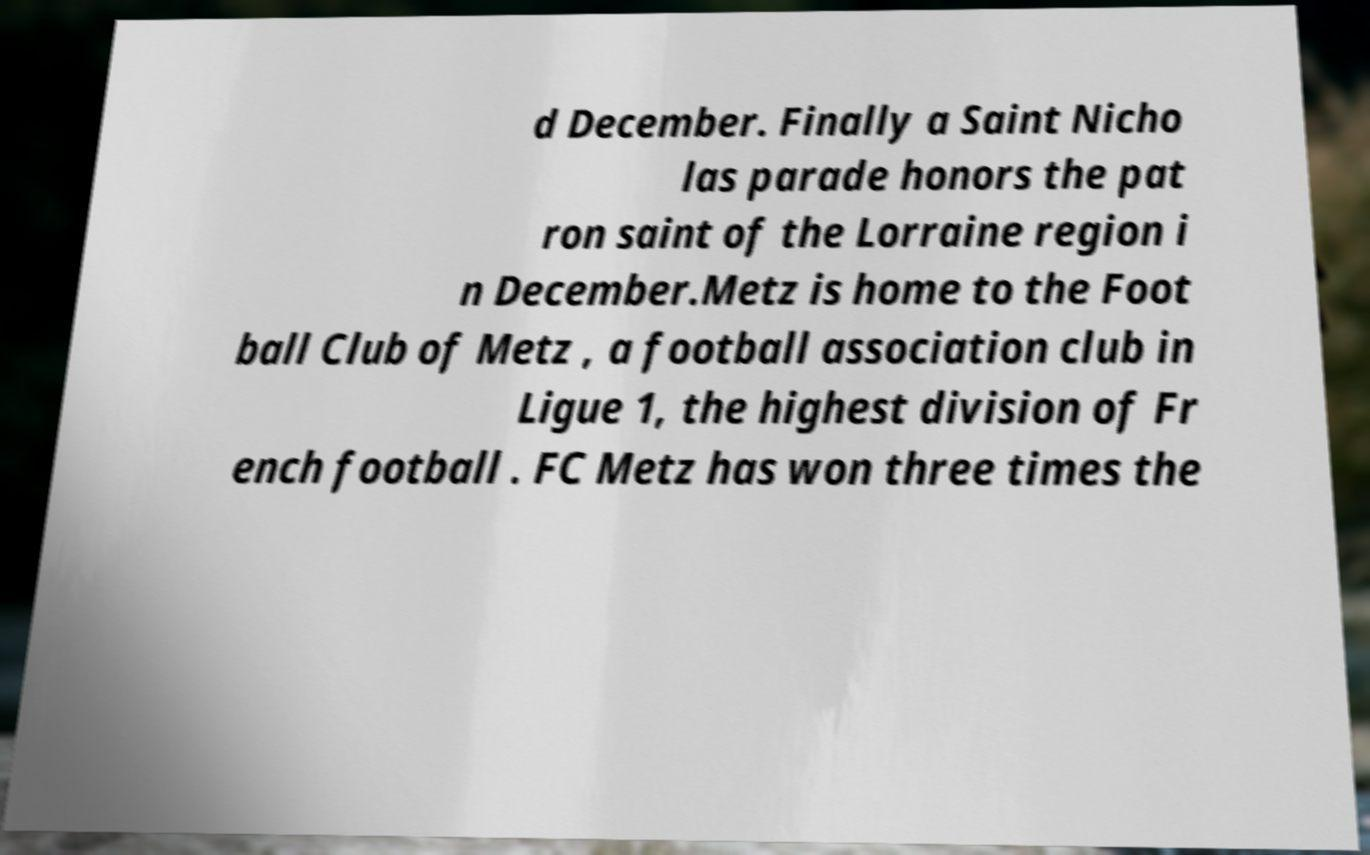Please read and relay the text visible in this image. What does it say? d December. Finally a Saint Nicho las parade honors the pat ron saint of the Lorraine region i n December.Metz is home to the Foot ball Club of Metz , a football association club in Ligue 1, the highest division of Fr ench football . FC Metz has won three times the 